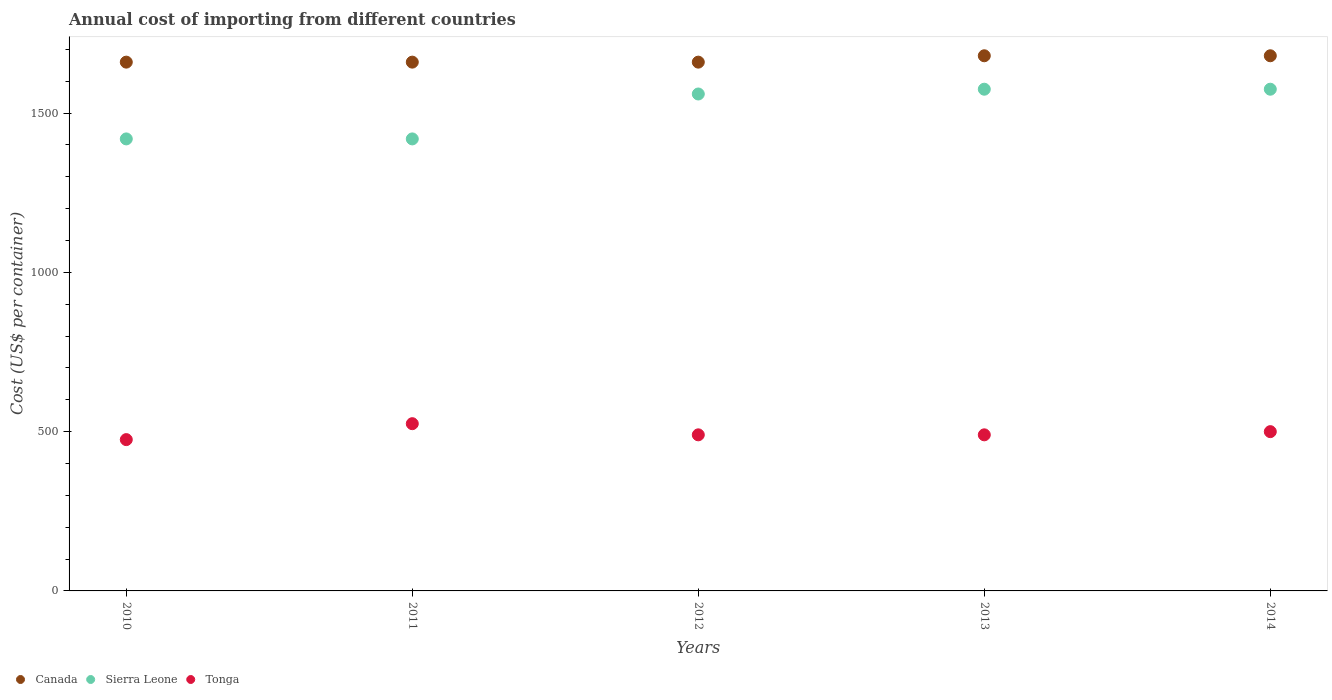How many different coloured dotlines are there?
Provide a succinct answer. 3. Is the number of dotlines equal to the number of legend labels?
Ensure brevity in your answer.  Yes. What is the total annual cost of importing in Canada in 2010?
Your response must be concise. 1660. Across all years, what is the maximum total annual cost of importing in Canada?
Provide a short and direct response. 1680. Across all years, what is the minimum total annual cost of importing in Canada?
Your answer should be compact. 1660. What is the total total annual cost of importing in Canada in the graph?
Your answer should be compact. 8340. What is the difference between the total annual cost of importing in Tonga in 2013 and the total annual cost of importing in Canada in 2012?
Your answer should be compact. -1170. What is the average total annual cost of importing in Tonga per year?
Provide a succinct answer. 496. In the year 2014, what is the difference between the total annual cost of importing in Canada and total annual cost of importing in Tonga?
Provide a succinct answer. 1180. In how many years, is the total annual cost of importing in Tonga greater than 900 US$?
Provide a short and direct response. 0. What is the ratio of the total annual cost of importing in Sierra Leone in 2010 to that in 2014?
Provide a succinct answer. 0.9. What is the difference between the highest and the second highest total annual cost of importing in Canada?
Offer a terse response. 0. What is the difference between the highest and the lowest total annual cost of importing in Canada?
Offer a very short reply. 20. In how many years, is the total annual cost of importing in Sierra Leone greater than the average total annual cost of importing in Sierra Leone taken over all years?
Make the answer very short. 3. Is it the case that in every year, the sum of the total annual cost of importing in Tonga and total annual cost of importing in Sierra Leone  is greater than the total annual cost of importing in Canada?
Offer a very short reply. Yes. Is the total annual cost of importing in Canada strictly greater than the total annual cost of importing in Sierra Leone over the years?
Your answer should be very brief. Yes. Is the total annual cost of importing in Tonga strictly less than the total annual cost of importing in Sierra Leone over the years?
Ensure brevity in your answer.  Yes. How many years are there in the graph?
Keep it short and to the point. 5. Does the graph contain any zero values?
Make the answer very short. No. Does the graph contain grids?
Keep it short and to the point. No. How are the legend labels stacked?
Offer a terse response. Horizontal. What is the title of the graph?
Provide a succinct answer. Annual cost of importing from different countries. What is the label or title of the Y-axis?
Your answer should be compact. Cost (US$ per container). What is the Cost (US$ per container) in Canada in 2010?
Your response must be concise. 1660. What is the Cost (US$ per container) of Sierra Leone in 2010?
Offer a very short reply. 1419. What is the Cost (US$ per container) of Tonga in 2010?
Offer a terse response. 475. What is the Cost (US$ per container) in Canada in 2011?
Provide a succinct answer. 1660. What is the Cost (US$ per container) of Sierra Leone in 2011?
Your answer should be compact. 1419. What is the Cost (US$ per container) of Tonga in 2011?
Offer a terse response. 525. What is the Cost (US$ per container) of Canada in 2012?
Provide a short and direct response. 1660. What is the Cost (US$ per container) of Sierra Leone in 2012?
Provide a short and direct response. 1560. What is the Cost (US$ per container) in Tonga in 2012?
Provide a short and direct response. 490. What is the Cost (US$ per container) of Canada in 2013?
Ensure brevity in your answer.  1680. What is the Cost (US$ per container) in Sierra Leone in 2013?
Offer a terse response. 1575. What is the Cost (US$ per container) in Tonga in 2013?
Keep it short and to the point. 490. What is the Cost (US$ per container) in Canada in 2014?
Keep it short and to the point. 1680. What is the Cost (US$ per container) in Sierra Leone in 2014?
Offer a terse response. 1575. What is the Cost (US$ per container) of Tonga in 2014?
Provide a succinct answer. 500. Across all years, what is the maximum Cost (US$ per container) in Canada?
Offer a terse response. 1680. Across all years, what is the maximum Cost (US$ per container) of Sierra Leone?
Your answer should be very brief. 1575. Across all years, what is the maximum Cost (US$ per container) of Tonga?
Offer a terse response. 525. Across all years, what is the minimum Cost (US$ per container) in Canada?
Your answer should be very brief. 1660. Across all years, what is the minimum Cost (US$ per container) of Sierra Leone?
Your response must be concise. 1419. Across all years, what is the minimum Cost (US$ per container) in Tonga?
Keep it short and to the point. 475. What is the total Cost (US$ per container) of Canada in the graph?
Your answer should be very brief. 8340. What is the total Cost (US$ per container) of Sierra Leone in the graph?
Your answer should be very brief. 7548. What is the total Cost (US$ per container) of Tonga in the graph?
Give a very brief answer. 2480. What is the difference between the Cost (US$ per container) in Sierra Leone in 2010 and that in 2011?
Your response must be concise. 0. What is the difference between the Cost (US$ per container) of Sierra Leone in 2010 and that in 2012?
Your answer should be compact. -141. What is the difference between the Cost (US$ per container) of Sierra Leone in 2010 and that in 2013?
Ensure brevity in your answer.  -156. What is the difference between the Cost (US$ per container) of Tonga in 2010 and that in 2013?
Your response must be concise. -15. What is the difference between the Cost (US$ per container) in Sierra Leone in 2010 and that in 2014?
Offer a very short reply. -156. What is the difference between the Cost (US$ per container) of Canada in 2011 and that in 2012?
Offer a terse response. 0. What is the difference between the Cost (US$ per container) of Sierra Leone in 2011 and that in 2012?
Ensure brevity in your answer.  -141. What is the difference between the Cost (US$ per container) in Canada in 2011 and that in 2013?
Give a very brief answer. -20. What is the difference between the Cost (US$ per container) of Sierra Leone in 2011 and that in 2013?
Make the answer very short. -156. What is the difference between the Cost (US$ per container) of Tonga in 2011 and that in 2013?
Provide a short and direct response. 35. What is the difference between the Cost (US$ per container) in Canada in 2011 and that in 2014?
Provide a short and direct response. -20. What is the difference between the Cost (US$ per container) in Sierra Leone in 2011 and that in 2014?
Give a very brief answer. -156. What is the difference between the Cost (US$ per container) in Sierra Leone in 2012 and that in 2013?
Ensure brevity in your answer.  -15. What is the difference between the Cost (US$ per container) in Tonga in 2012 and that in 2013?
Provide a short and direct response. 0. What is the difference between the Cost (US$ per container) in Canada in 2012 and that in 2014?
Make the answer very short. -20. What is the difference between the Cost (US$ per container) of Canada in 2013 and that in 2014?
Provide a succinct answer. 0. What is the difference between the Cost (US$ per container) of Canada in 2010 and the Cost (US$ per container) of Sierra Leone in 2011?
Your answer should be very brief. 241. What is the difference between the Cost (US$ per container) of Canada in 2010 and the Cost (US$ per container) of Tonga in 2011?
Your response must be concise. 1135. What is the difference between the Cost (US$ per container) of Sierra Leone in 2010 and the Cost (US$ per container) of Tonga in 2011?
Offer a terse response. 894. What is the difference between the Cost (US$ per container) in Canada in 2010 and the Cost (US$ per container) in Sierra Leone in 2012?
Offer a terse response. 100. What is the difference between the Cost (US$ per container) in Canada in 2010 and the Cost (US$ per container) in Tonga in 2012?
Offer a terse response. 1170. What is the difference between the Cost (US$ per container) in Sierra Leone in 2010 and the Cost (US$ per container) in Tonga in 2012?
Keep it short and to the point. 929. What is the difference between the Cost (US$ per container) of Canada in 2010 and the Cost (US$ per container) of Sierra Leone in 2013?
Ensure brevity in your answer.  85. What is the difference between the Cost (US$ per container) in Canada in 2010 and the Cost (US$ per container) in Tonga in 2013?
Provide a succinct answer. 1170. What is the difference between the Cost (US$ per container) of Sierra Leone in 2010 and the Cost (US$ per container) of Tonga in 2013?
Provide a succinct answer. 929. What is the difference between the Cost (US$ per container) of Canada in 2010 and the Cost (US$ per container) of Tonga in 2014?
Your answer should be very brief. 1160. What is the difference between the Cost (US$ per container) of Sierra Leone in 2010 and the Cost (US$ per container) of Tonga in 2014?
Keep it short and to the point. 919. What is the difference between the Cost (US$ per container) of Canada in 2011 and the Cost (US$ per container) of Tonga in 2012?
Provide a short and direct response. 1170. What is the difference between the Cost (US$ per container) in Sierra Leone in 2011 and the Cost (US$ per container) in Tonga in 2012?
Provide a succinct answer. 929. What is the difference between the Cost (US$ per container) in Canada in 2011 and the Cost (US$ per container) in Sierra Leone in 2013?
Give a very brief answer. 85. What is the difference between the Cost (US$ per container) in Canada in 2011 and the Cost (US$ per container) in Tonga in 2013?
Provide a succinct answer. 1170. What is the difference between the Cost (US$ per container) of Sierra Leone in 2011 and the Cost (US$ per container) of Tonga in 2013?
Provide a short and direct response. 929. What is the difference between the Cost (US$ per container) in Canada in 2011 and the Cost (US$ per container) in Tonga in 2014?
Offer a very short reply. 1160. What is the difference between the Cost (US$ per container) in Sierra Leone in 2011 and the Cost (US$ per container) in Tonga in 2014?
Your answer should be very brief. 919. What is the difference between the Cost (US$ per container) of Canada in 2012 and the Cost (US$ per container) of Sierra Leone in 2013?
Offer a terse response. 85. What is the difference between the Cost (US$ per container) of Canada in 2012 and the Cost (US$ per container) of Tonga in 2013?
Give a very brief answer. 1170. What is the difference between the Cost (US$ per container) of Sierra Leone in 2012 and the Cost (US$ per container) of Tonga in 2013?
Your answer should be compact. 1070. What is the difference between the Cost (US$ per container) in Canada in 2012 and the Cost (US$ per container) in Tonga in 2014?
Ensure brevity in your answer.  1160. What is the difference between the Cost (US$ per container) of Sierra Leone in 2012 and the Cost (US$ per container) of Tonga in 2014?
Your answer should be compact. 1060. What is the difference between the Cost (US$ per container) in Canada in 2013 and the Cost (US$ per container) in Sierra Leone in 2014?
Offer a very short reply. 105. What is the difference between the Cost (US$ per container) of Canada in 2013 and the Cost (US$ per container) of Tonga in 2014?
Offer a very short reply. 1180. What is the difference between the Cost (US$ per container) of Sierra Leone in 2013 and the Cost (US$ per container) of Tonga in 2014?
Keep it short and to the point. 1075. What is the average Cost (US$ per container) in Canada per year?
Make the answer very short. 1668. What is the average Cost (US$ per container) of Sierra Leone per year?
Offer a terse response. 1509.6. What is the average Cost (US$ per container) of Tonga per year?
Your answer should be very brief. 496. In the year 2010, what is the difference between the Cost (US$ per container) of Canada and Cost (US$ per container) of Sierra Leone?
Provide a short and direct response. 241. In the year 2010, what is the difference between the Cost (US$ per container) in Canada and Cost (US$ per container) in Tonga?
Keep it short and to the point. 1185. In the year 2010, what is the difference between the Cost (US$ per container) in Sierra Leone and Cost (US$ per container) in Tonga?
Offer a very short reply. 944. In the year 2011, what is the difference between the Cost (US$ per container) in Canada and Cost (US$ per container) in Sierra Leone?
Provide a short and direct response. 241. In the year 2011, what is the difference between the Cost (US$ per container) in Canada and Cost (US$ per container) in Tonga?
Provide a short and direct response. 1135. In the year 2011, what is the difference between the Cost (US$ per container) in Sierra Leone and Cost (US$ per container) in Tonga?
Give a very brief answer. 894. In the year 2012, what is the difference between the Cost (US$ per container) of Canada and Cost (US$ per container) of Tonga?
Your answer should be compact. 1170. In the year 2012, what is the difference between the Cost (US$ per container) of Sierra Leone and Cost (US$ per container) of Tonga?
Offer a very short reply. 1070. In the year 2013, what is the difference between the Cost (US$ per container) of Canada and Cost (US$ per container) of Sierra Leone?
Offer a very short reply. 105. In the year 2013, what is the difference between the Cost (US$ per container) of Canada and Cost (US$ per container) of Tonga?
Your response must be concise. 1190. In the year 2013, what is the difference between the Cost (US$ per container) of Sierra Leone and Cost (US$ per container) of Tonga?
Your response must be concise. 1085. In the year 2014, what is the difference between the Cost (US$ per container) in Canada and Cost (US$ per container) in Sierra Leone?
Your response must be concise. 105. In the year 2014, what is the difference between the Cost (US$ per container) in Canada and Cost (US$ per container) in Tonga?
Provide a short and direct response. 1180. In the year 2014, what is the difference between the Cost (US$ per container) in Sierra Leone and Cost (US$ per container) in Tonga?
Make the answer very short. 1075. What is the ratio of the Cost (US$ per container) of Canada in 2010 to that in 2011?
Provide a short and direct response. 1. What is the ratio of the Cost (US$ per container) of Tonga in 2010 to that in 2011?
Make the answer very short. 0.9. What is the ratio of the Cost (US$ per container) of Sierra Leone in 2010 to that in 2012?
Your answer should be compact. 0.91. What is the ratio of the Cost (US$ per container) in Tonga in 2010 to that in 2012?
Your answer should be compact. 0.97. What is the ratio of the Cost (US$ per container) of Canada in 2010 to that in 2013?
Give a very brief answer. 0.99. What is the ratio of the Cost (US$ per container) in Sierra Leone in 2010 to that in 2013?
Give a very brief answer. 0.9. What is the ratio of the Cost (US$ per container) of Tonga in 2010 to that in 2013?
Make the answer very short. 0.97. What is the ratio of the Cost (US$ per container) of Canada in 2010 to that in 2014?
Ensure brevity in your answer.  0.99. What is the ratio of the Cost (US$ per container) of Sierra Leone in 2010 to that in 2014?
Make the answer very short. 0.9. What is the ratio of the Cost (US$ per container) in Sierra Leone in 2011 to that in 2012?
Provide a succinct answer. 0.91. What is the ratio of the Cost (US$ per container) in Tonga in 2011 to that in 2012?
Offer a very short reply. 1.07. What is the ratio of the Cost (US$ per container) of Sierra Leone in 2011 to that in 2013?
Your answer should be very brief. 0.9. What is the ratio of the Cost (US$ per container) in Tonga in 2011 to that in 2013?
Provide a succinct answer. 1.07. What is the ratio of the Cost (US$ per container) of Canada in 2011 to that in 2014?
Keep it short and to the point. 0.99. What is the ratio of the Cost (US$ per container) in Sierra Leone in 2011 to that in 2014?
Provide a succinct answer. 0.9. What is the ratio of the Cost (US$ per container) of Tonga in 2011 to that in 2014?
Offer a terse response. 1.05. What is the ratio of the Cost (US$ per container) of Canada in 2012 to that in 2014?
Offer a very short reply. 0.99. What is the ratio of the Cost (US$ per container) in Sierra Leone in 2012 to that in 2014?
Offer a very short reply. 0.99. What is the ratio of the Cost (US$ per container) in Canada in 2013 to that in 2014?
Provide a short and direct response. 1. What is the ratio of the Cost (US$ per container) of Tonga in 2013 to that in 2014?
Provide a succinct answer. 0.98. What is the difference between the highest and the second highest Cost (US$ per container) of Canada?
Make the answer very short. 0. What is the difference between the highest and the second highest Cost (US$ per container) of Sierra Leone?
Give a very brief answer. 0. What is the difference between the highest and the second highest Cost (US$ per container) in Tonga?
Make the answer very short. 25. What is the difference between the highest and the lowest Cost (US$ per container) in Sierra Leone?
Your answer should be very brief. 156. What is the difference between the highest and the lowest Cost (US$ per container) in Tonga?
Your answer should be very brief. 50. 